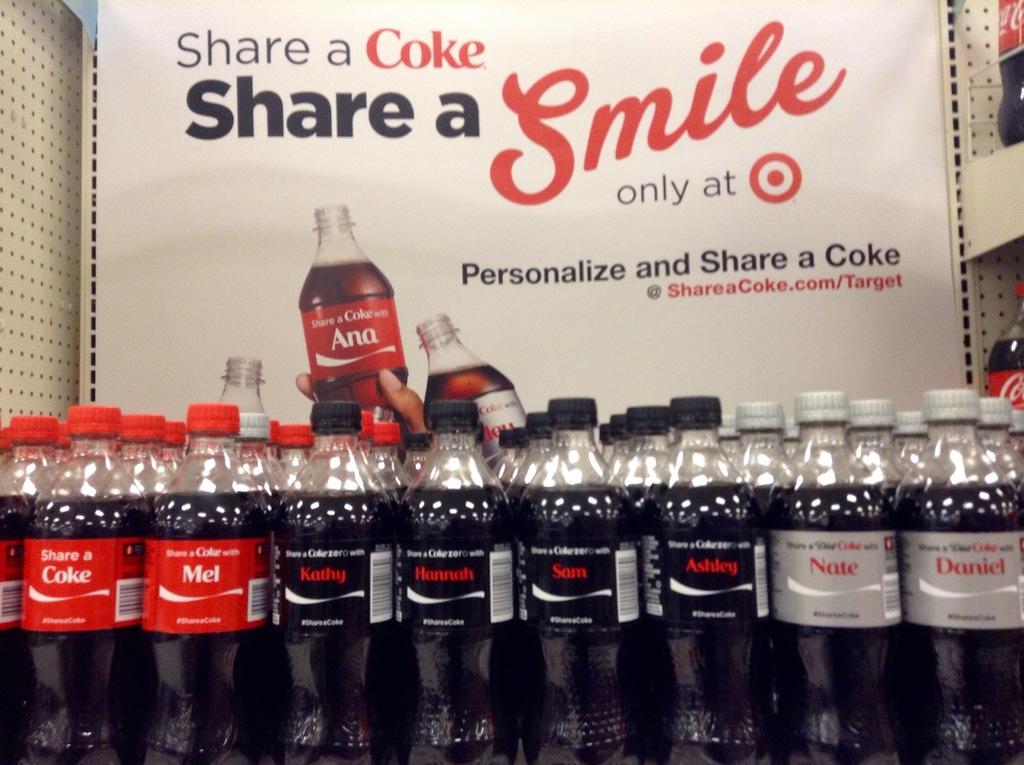What does this ad want you to share?
Your response must be concise. A coke. What is the name on the bottle in the advertisement?
Your answer should be very brief. Ana. 